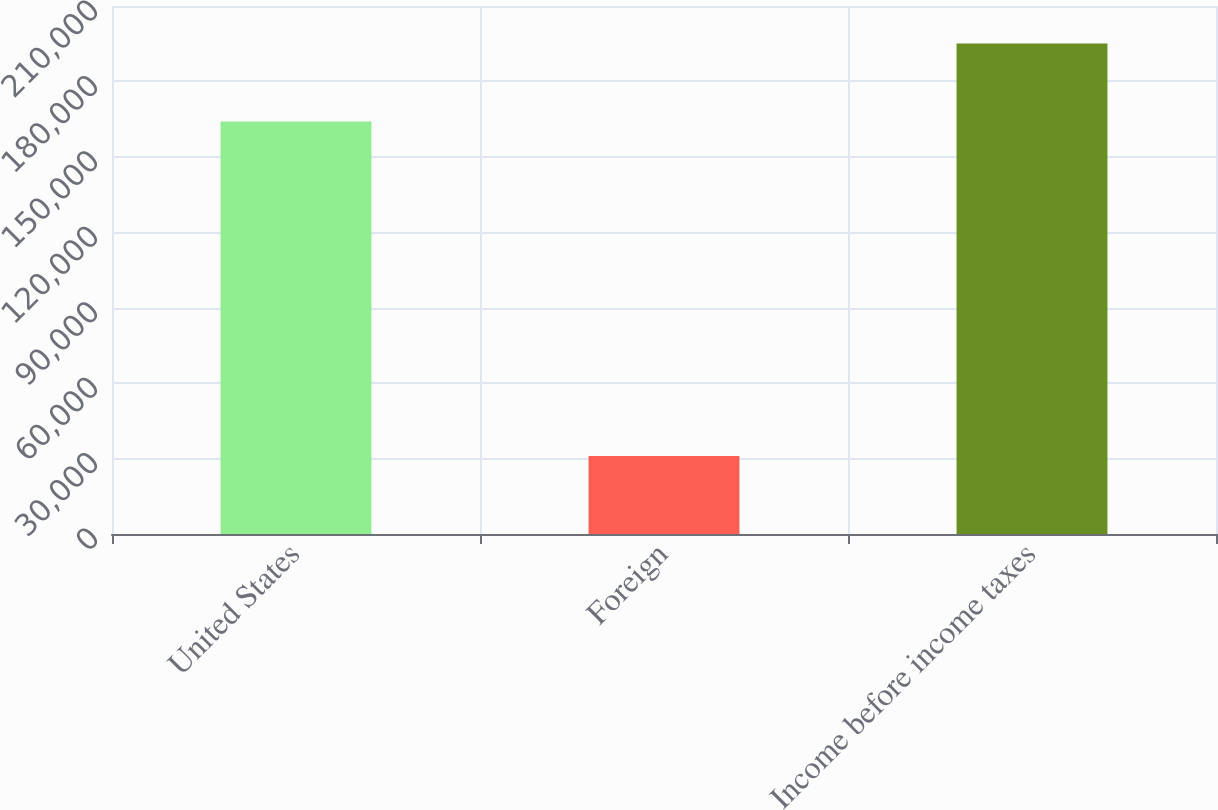Convert chart to OTSL. <chart><loc_0><loc_0><loc_500><loc_500><bar_chart><fcel>United States<fcel>Foreign<fcel>Income before income taxes<nl><fcel>164094<fcel>30980<fcel>195074<nl></chart> 